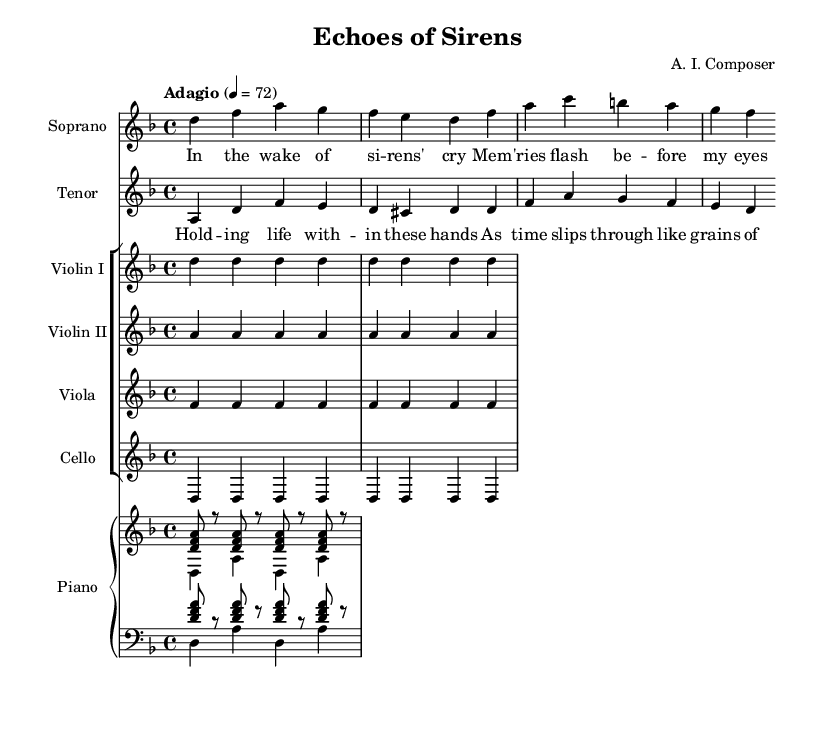What is the key signature of this music? The music is in D minor, which has one flat (B flat). This is indicated at the beginning of the sheet music before the first measure.
Answer: D minor What is the time signature of this piece? The time signature is 4/4, shown at the beginning of the score. This means there are four beats in each measure, and the quarter note gets one beat.
Answer: 4/4 What is the tempo marking for this piece? The tempo marking is "Adagio," indicating a slow pace. The specific metronome marking is 72 beats per minute.
Answer: Adagio How many measures are in the soprano's part? The soprano part consists of two measures, recognizable by the two sets of music notation separated by vertical lines indicating measure boundaries.
Answer: Two measures What is the dynamic marking for the piano? There is no dynamic marking provided in this score for the piano part, indicating that the piece may be performed at a medium volume unless otherwise specified by the performers.
Answer: No dynamic marking What lyrics are sung by the tenor? The tenor lyrics are "Holding life within these hands, as time slips through like grains of sand." This can be confirmed by reading the corresponding text under the notes in the tenor staff.
Answer: Holding life within these hands, as time slips through like grains of sand How many instruments are included in the ensemble? There are six instruments in total: two violins, one viola, one cello, and one piano, along with two vocal parts (soprano and tenor). This is indicated by the staff groups in the score.
Answer: Six instruments 